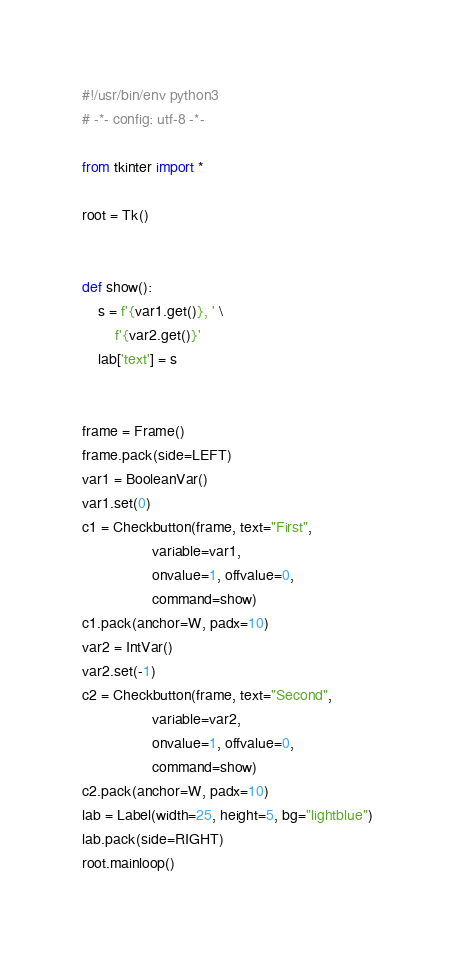Convert code to text. <code><loc_0><loc_0><loc_500><loc_500><_Python_>#!/usr/bin/env python3
# -*- config: utf-8 -*-

from tkinter import *

root = Tk()


def show():
    s = f'{var1.get()}, ' \
        f'{var2.get()}'
    lab['text'] = s


frame = Frame()
frame.pack(side=LEFT)
var1 = BooleanVar()
var1.set(0)
c1 = Checkbutton(frame, text="First",
                 variable=var1,
                 onvalue=1, offvalue=0,
                 command=show)
c1.pack(anchor=W, padx=10)
var2 = IntVar()
var2.set(-1)
c2 = Checkbutton(frame, text="Second",
                 variable=var2,
                 onvalue=1, offvalue=0,
                 command=show)
c2.pack(anchor=W, padx=10)
lab = Label(width=25, height=5, bg="lightblue")
lab.pack(side=RIGHT)
root.mainloop()
</code> 